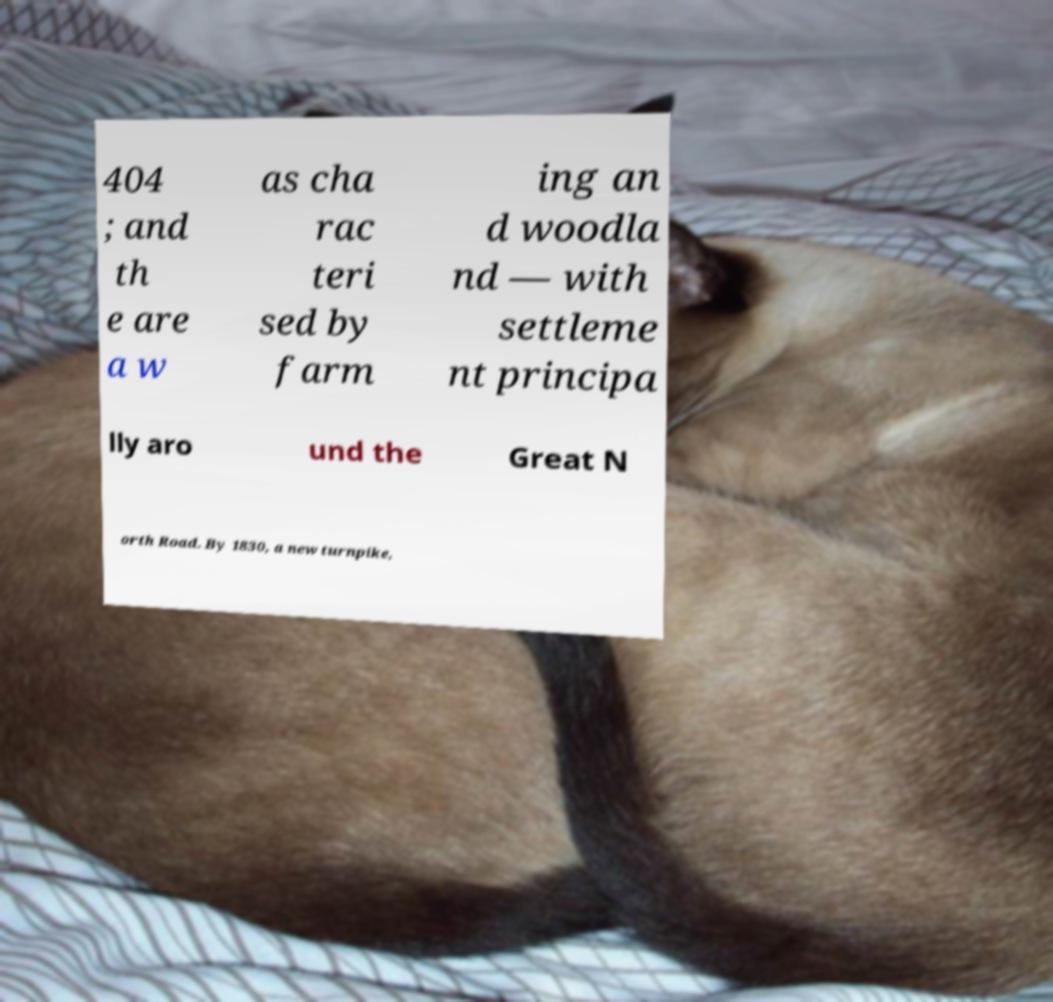Please identify and transcribe the text found in this image. 404 ; and th e are a w as cha rac teri sed by farm ing an d woodla nd — with settleme nt principa lly aro und the Great N orth Road. By 1830, a new turnpike, 